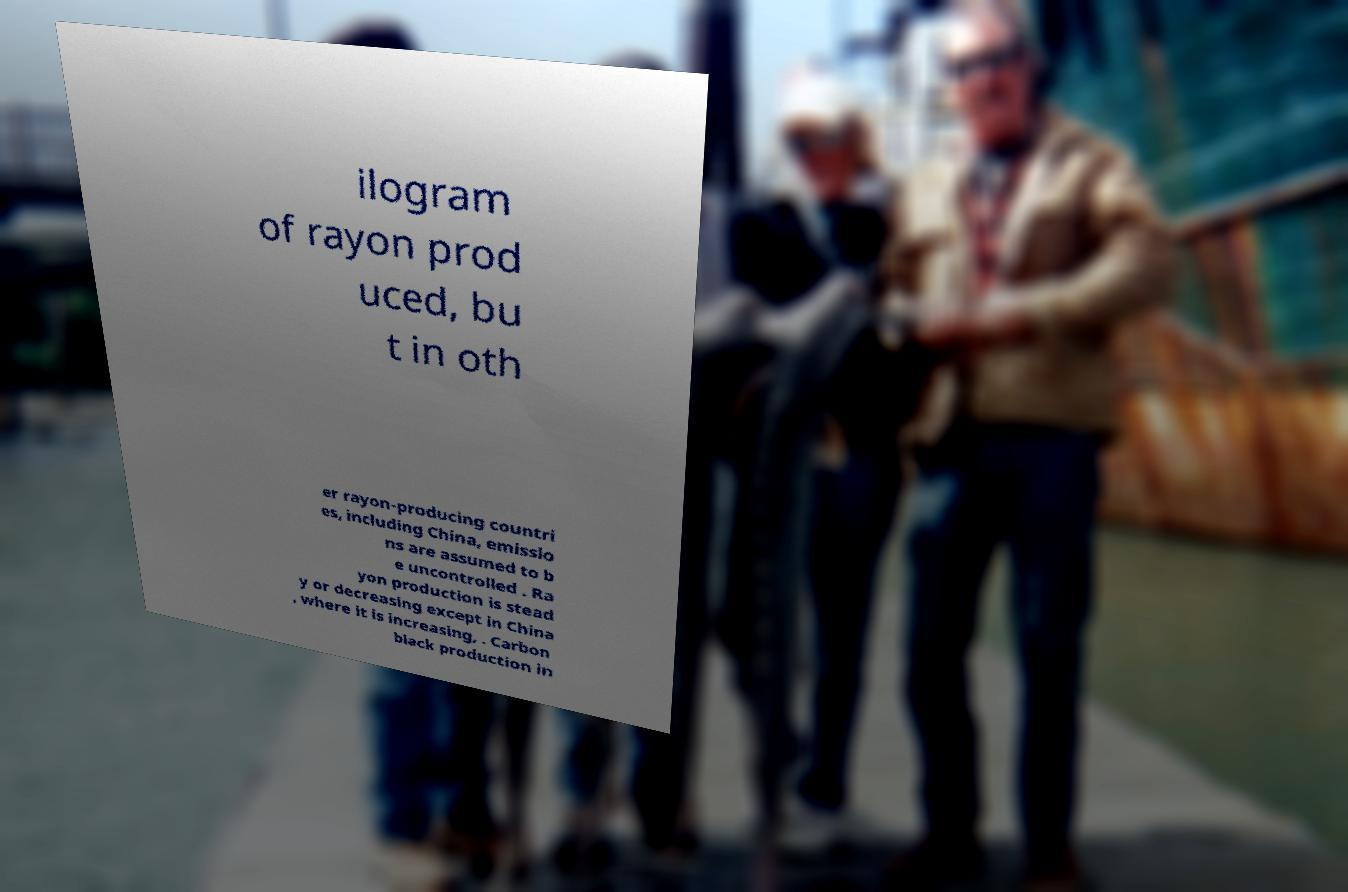Can you accurately transcribe the text from the provided image for me? ilogram of rayon prod uced, bu t in oth er rayon-producing countri es, including China, emissio ns are assumed to b e uncontrolled . Ra yon production is stead y or decreasing except in China , where it is increasing, . Carbon black production in 